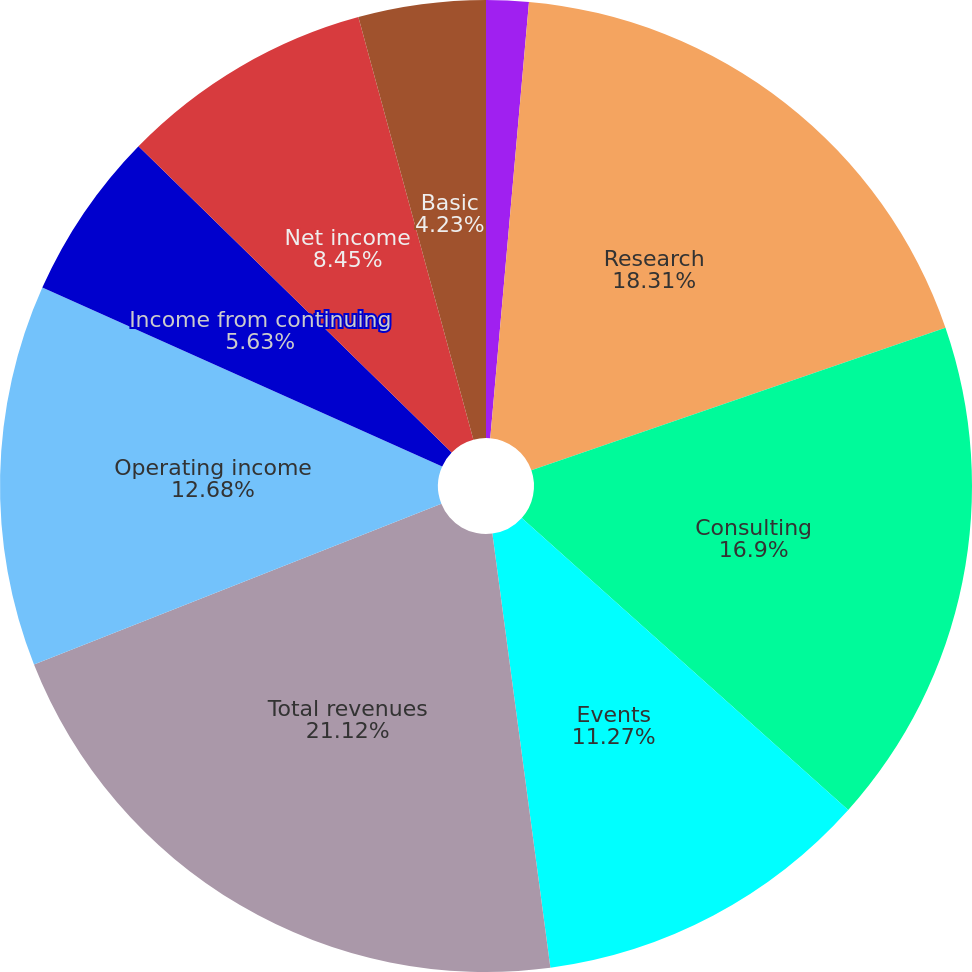<chart> <loc_0><loc_0><loc_500><loc_500><pie_chart><fcel>(In thousands except per share<fcel>Research<fcel>Consulting<fcel>Events<fcel>Total revenues<fcel>Operating income<fcel>Income from continuing<fcel>Net income<fcel>Income per share<fcel>Basic<nl><fcel>1.41%<fcel>18.31%<fcel>16.9%<fcel>11.27%<fcel>21.13%<fcel>12.68%<fcel>5.63%<fcel>8.45%<fcel>0.0%<fcel>4.23%<nl></chart> 